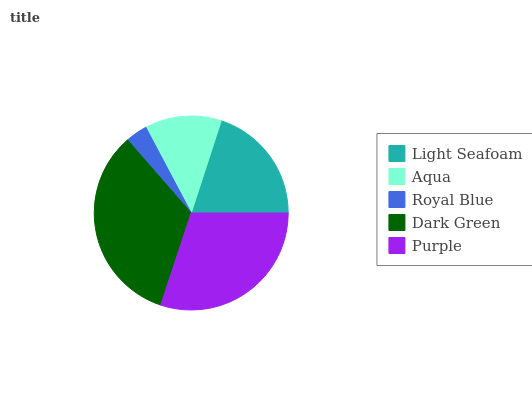Is Royal Blue the minimum?
Answer yes or no. Yes. Is Dark Green the maximum?
Answer yes or no. Yes. Is Aqua the minimum?
Answer yes or no. No. Is Aqua the maximum?
Answer yes or no. No. Is Light Seafoam greater than Aqua?
Answer yes or no. Yes. Is Aqua less than Light Seafoam?
Answer yes or no. Yes. Is Aqua greater than Light Seafoam?
Answer yes or no. No. Is Light Seafoam less than Aqua?
Answer yes or no. No. Is Light Seafoam the high median?
Answer yes or no. Yes. Is Light Seafoam the low median?
Answer yes or no. Yes. Is Purple the high median?
Answer yes or no. No. Is Aqua the low median?
Answer yes or no. No. 